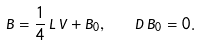Convert formula to latex. <formula><loc_0><loc_0><loc_500><loc_500>B = \frac { 1 } { 4 } \, L \, V + B _ { 0 } , \quad D \, B _ { 0 } = 0 .</formula> 